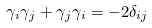<formula> <loc_0><loc_0><loc_500><loc_500>\gamma _ { i } \gamma _ { j } + \gamma _ { j } \gamma _ { i } = - 2 \delta _ { i j }</formula> 